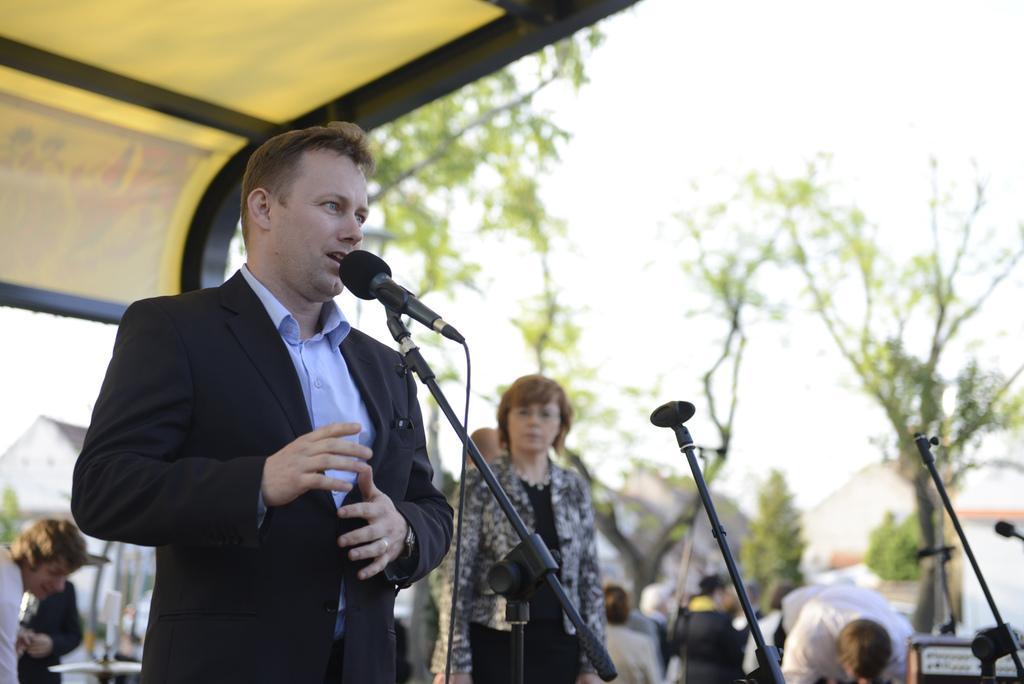Describe this image in one or two sentences. On the left side of the image, we can see a man talking in-front of a microphone with wire and stand. Here we can see rods. In the background, we can see the people, houses, trees, plants, few objects and sky. 